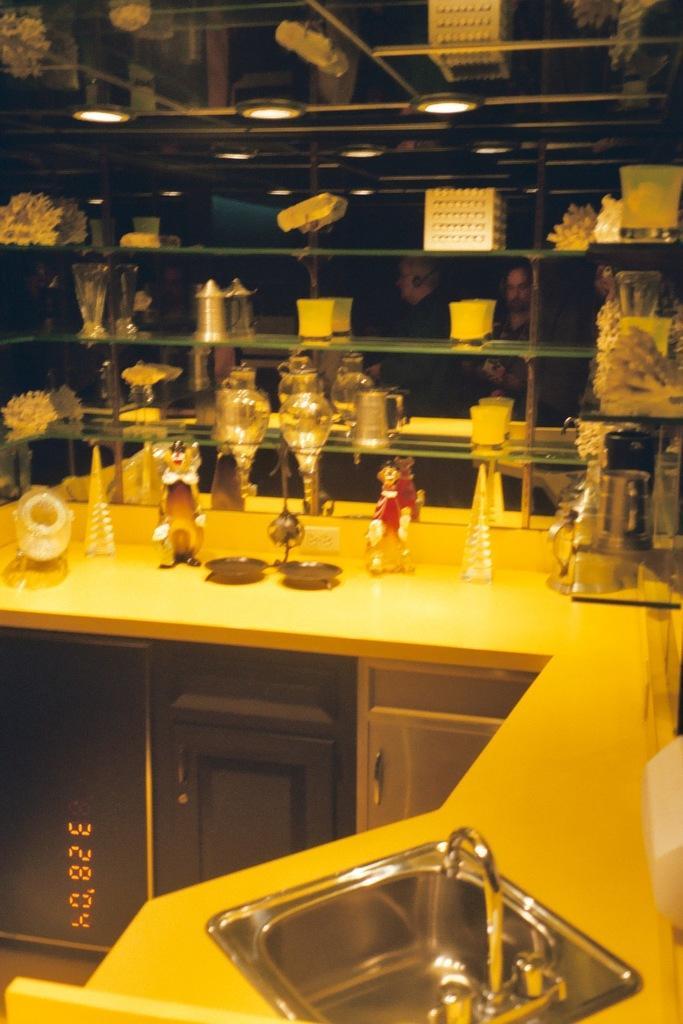Describe this image in one or two sentences. In this image we can see some objects placed in the shelves, two dolls, some objects and a sink on a counter-top. We can also see the cupboards, some digital numbers and some ceiling lights to a roof. 